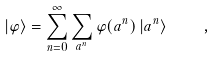<formula> <loc_0><loc_0><loc_500><loc_500>| \varphi \rangle = \sum _ { n = 0 } ^ { \infty } \sum _ { a ^ { n } } \varphi ( a ^ { n } ) \, | a ^ { n } \rangle \quad ,</formula> 